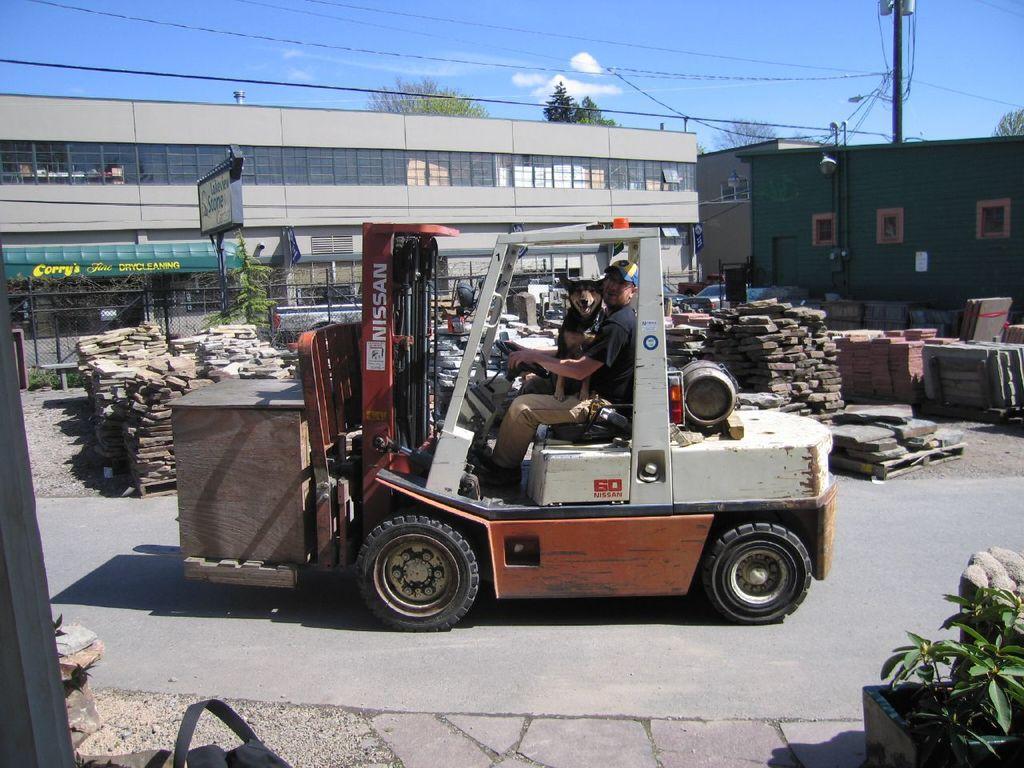In one or two sentences, can you explain what this image depicts? In this picture there is a man who is sitting on the vehicle. Beside him there is a dog. In the back I can see the wood. In the background I can see the buildings. On the right I can see the electric poles, street lights and wires. Behind the building I can see the trees. At the top I can see the sky and clouds. In the bottom right corner I can see some plants. 